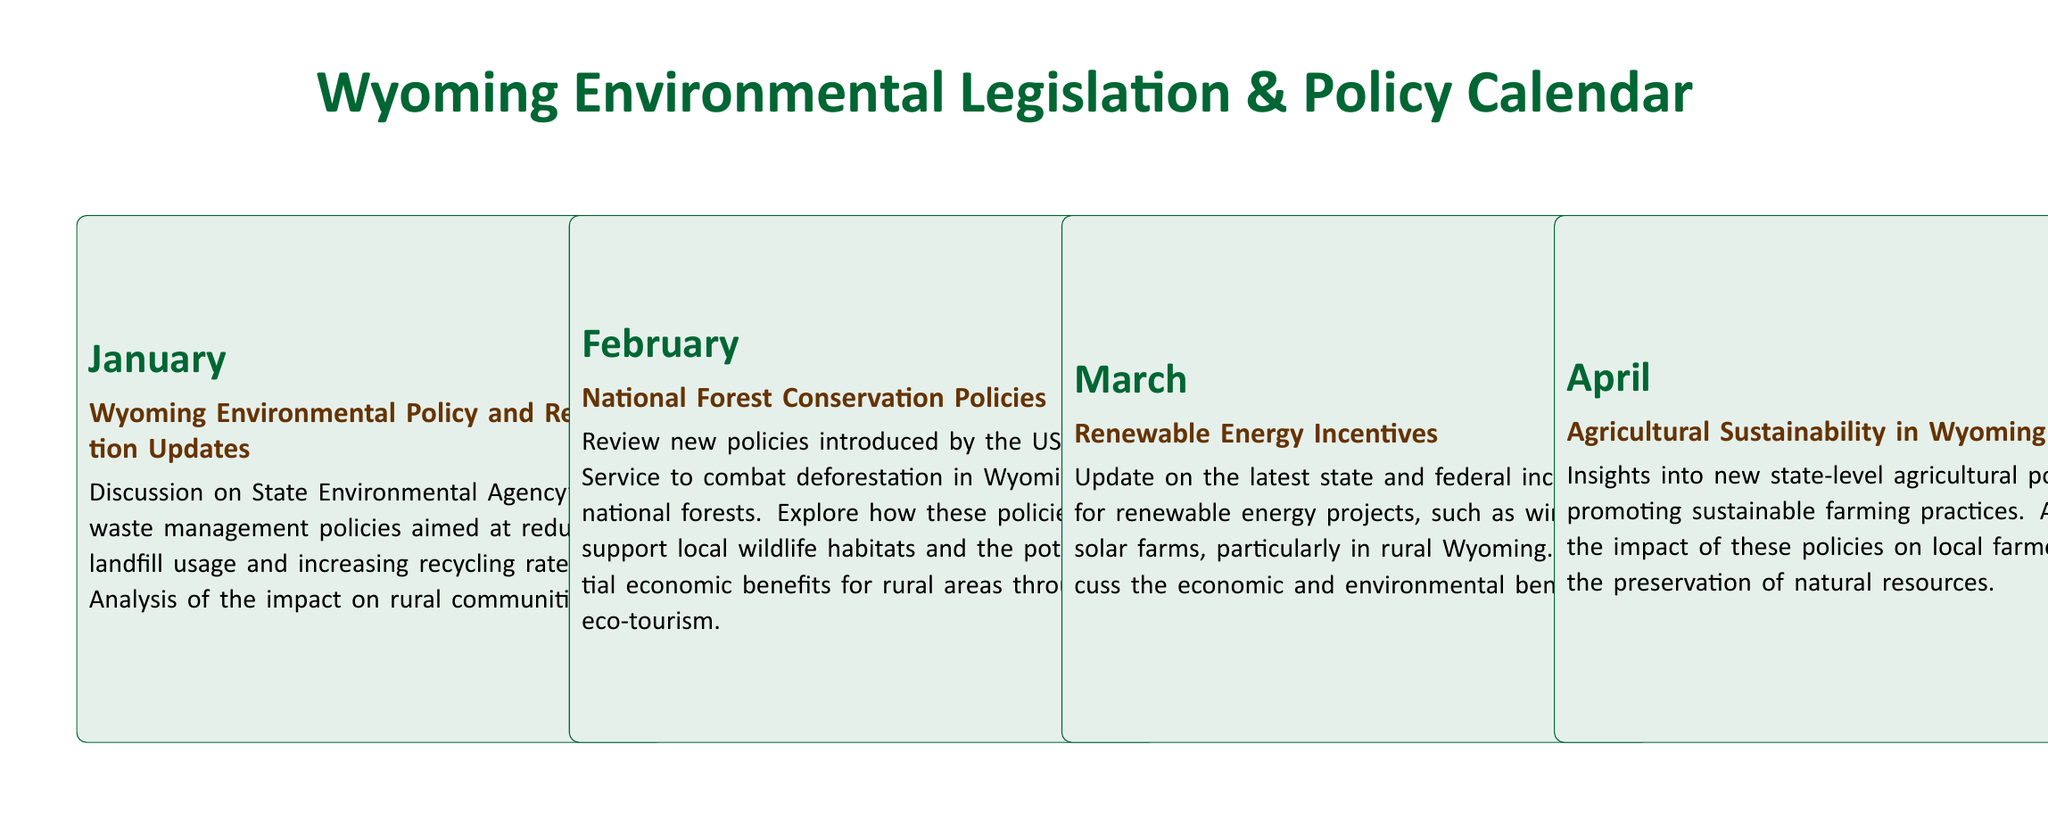What month focuses on waste management policies? The document highlights January for discussions on waste management policies aimed at reducing landfill usage and increasing recycling rates.
Answer: January Which month covers agricultural sustainability? The document specifies April for insights into new state-level agricultural policies promoting sustainable farming practices.
Answer: April What is the main topic for June? According to the document, June covers climate change adaptation strategies introduced by the state government.
Answer: Climate Change Adaptation Strategies How many months discuss renewable energy? The document mentions renewable energy in March and November, totaling two months.
Answer: 2 What is emphasized in the October section? The document focuses on the health impact of recent environmental policies in Wyoming for October.
Answer: Health Impact of Environmental Policies Which month highlights recycling programs? The document indicates September for highlighting recent updates to statewide recycling programs.
Answer: September What is the purpose of the initiatives in August? The document describes initiatives in August for upgrading rural infrastructure to support green technologies.
Answer: Enhancing Rural Infrastructure for Green Technology What year is being summarized in December? The document refers to a year-end review of major environmental legislations and policy updates for 2023.
Answer: 2023 What is the primary focus of July? The document states that July is focused on policies aimed at protecting endangered species in Wyoming.
Answer: Endangered Species Protection Efforts 